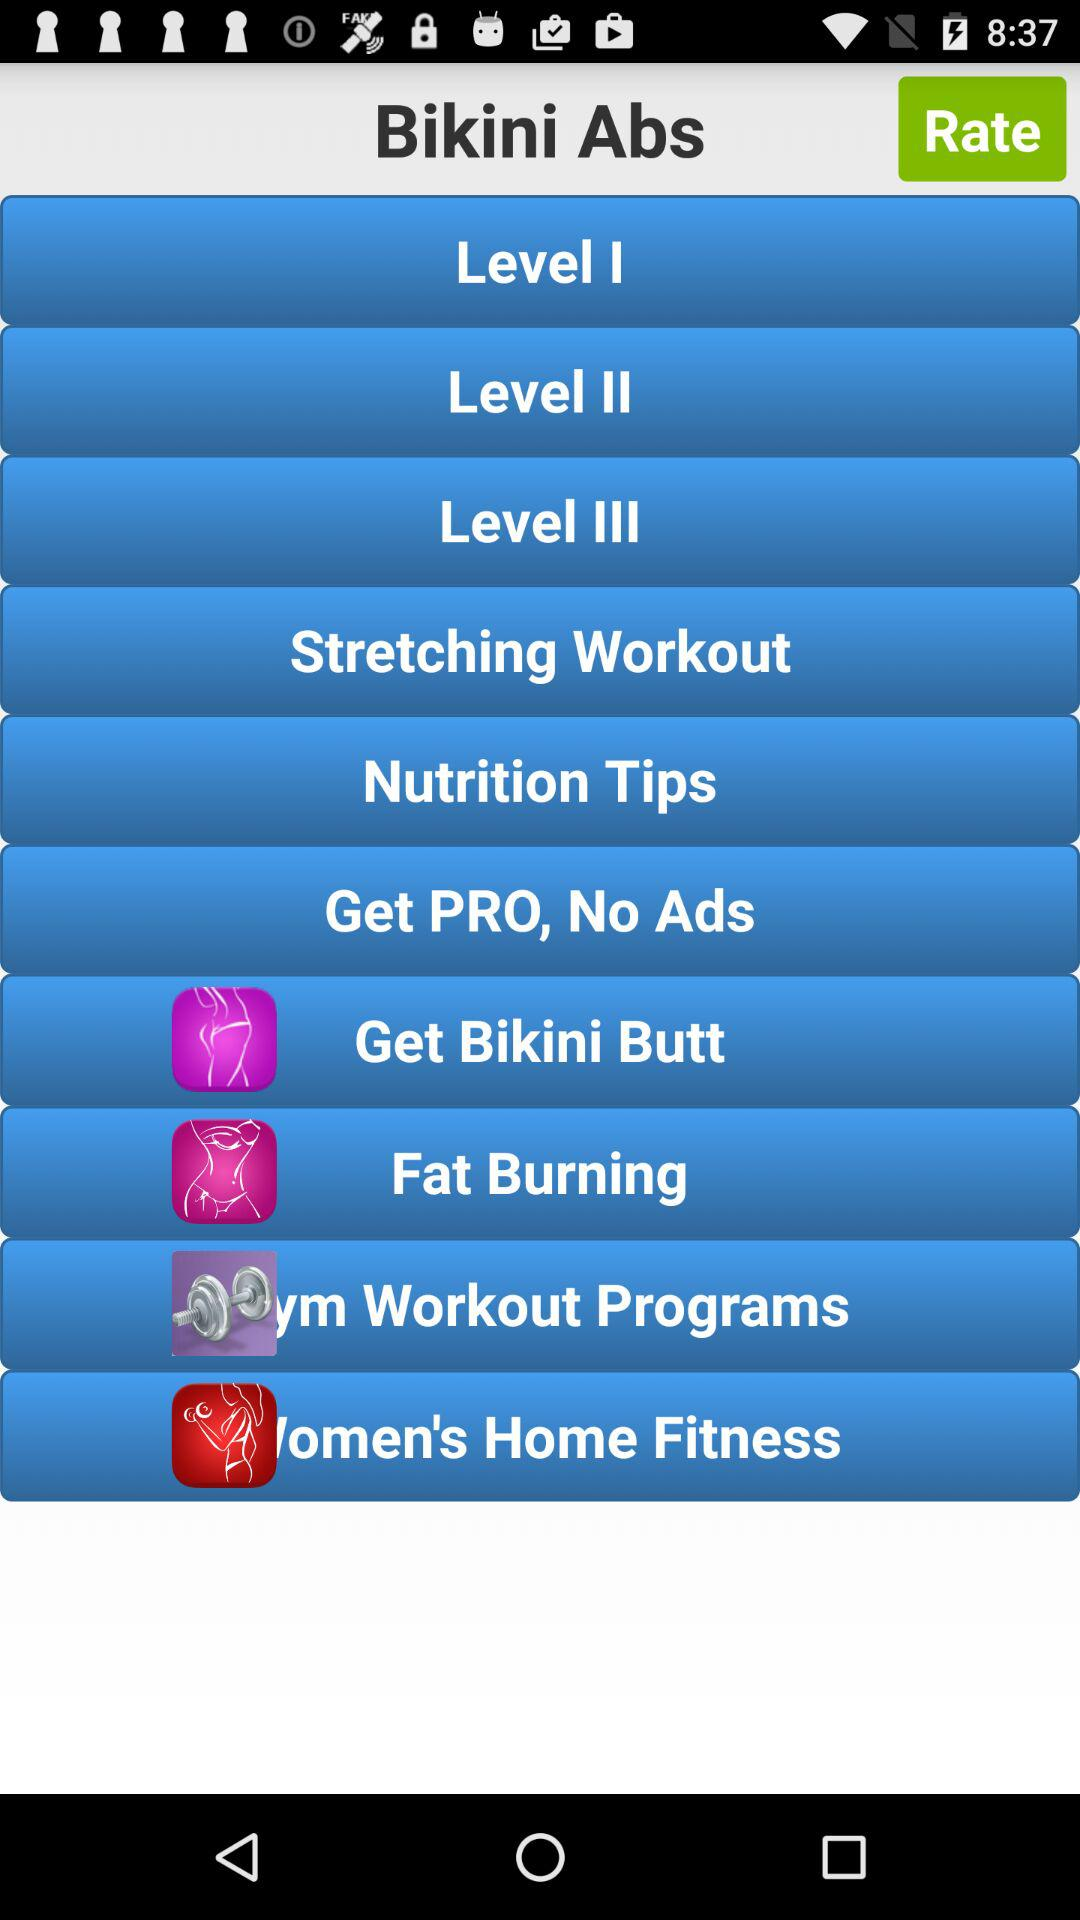Which bikini ab exercises are available in level 1?
When the provided information is insufficient, respond with <no answer>. <no answer> 